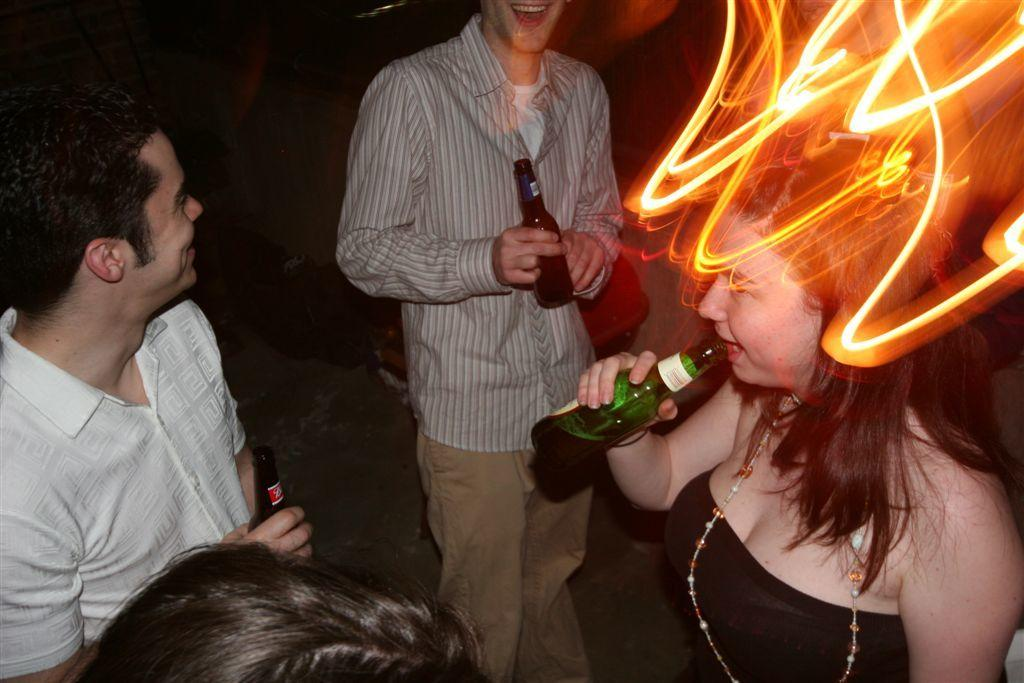How many people are in the image? There are three persons standing in the image. What are the persons holding? The persons are holding bottles. Can you describe the woman's appearance? The woman is wearing a pearl chain. What is the woman doing in the image? The woman is drinking. Is there any unusual feature on the woman's head? Yes, there is a light on the woman's head. What type of game is the woman playing with the key in the image? There is no key or game present in the image. What is the relation between the persons in the image? The provided facts do not give any information about the relationship between the persons in the image. 